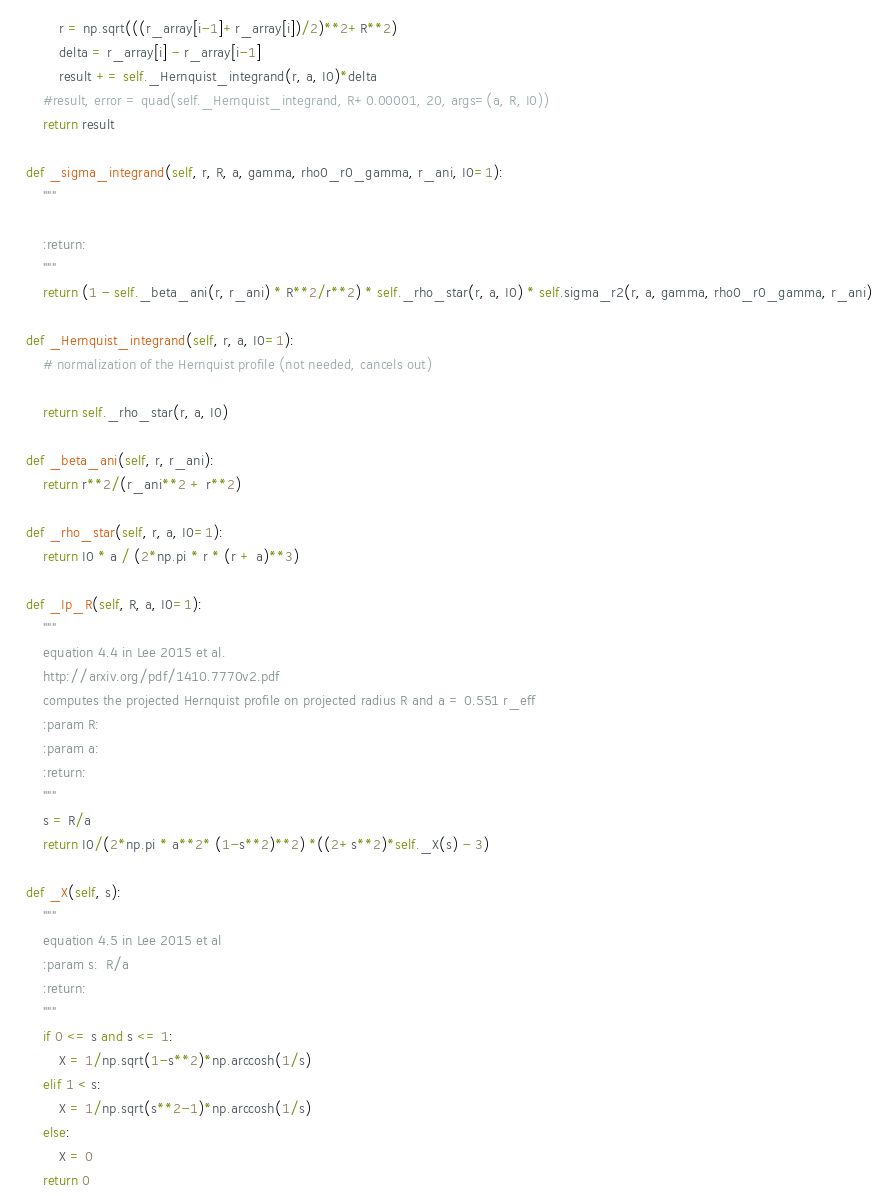<code> <loc_0><loc_0><loc_500><loc_500><_Python_>            r = np.sqrt(((r_array[i-1]+r_array[i])/2)**2+R**2)
            delta = r_array[i] - r_array[i-1]
            result += self._Hernquist_integrand(r, a, I0)*delta
        #result, error = quad(self._Hernquist_integrand, R+0.00001, 20, args=(a, R, I0))
        return result

    def _sigma_integrand(self, r, R, a, gamma, rho0_r0_gamma, r_ani, I0=1):
        """

        :return:
        """
        return (1 - self._beta_ani(r, r_ani) * R**2/r**2) * self._rho_star(r, a, I0) * self.sigma_r2(r, a, gamma, rho0_r0_gamma, r_ani)

    def _Hernquist_integrand(self, r, a, I0=1):
        # normalization of the Hernquist profile (not needed, cancels out)

        return self._rho_star(r, a, I0)

    def _beta_ani(self, r, r_ani):
        return r**2/(r_ani**2 + r**2)

    def _rho_star(self, r, a, I0=1):
        return I0 * a / (2*np.pi * r * (r + a)**3)

    def _Ip_R(self, R, a, I0=1):
        """
        equation 4.4 in Lee 2015 et al.
        http://arxiv.org/pdf/1410.7770v2.pdf
        computes the projected Hernquist profile on projected radius R and a = 0.551 r_eff
        :param R:
        :param a:
        :return:
        """
        s = R/a
        return I0/(2*np.pi * a**2* (1-s**2)**2) *((2+s**2)*self._X(s) - 3)

    def _X(self, s):
        """
        equation 4.5 in Lee 2015 et al
        :param s:  R/a
        :return:
        """
        if 0 <= s and s <= 1:
            X = 1/np.sqrt(1-s**2)*np.arccosh(1/s)
        elif 1 < s:
            X = 1/np.sqrt(s**2-1)*np.arccosh(1/s)
        else:
            X = 0
        return 0</code> 